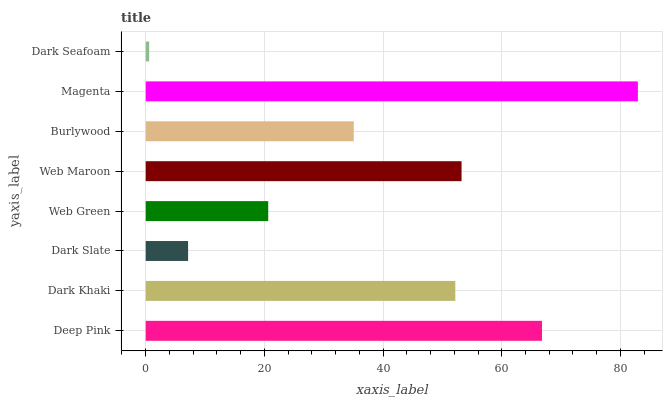Is Dark Seafoam the minimum?
Answer yes or no. Yes. Is Magenta the maximum?
Answer yes or no. Yes. Is Dark Khaki the minimum?
Answer yes or no. No. Is Dark Khaki the maximum?
Answer yes or no. No. Is Deep Pink greater than Dark Khaki?
Answer yes or no. Yes. Is Dark Khaki less than Deep Pink?
Answer yes or no. Yes. Is Dark Khaki greater than Deep Pink?
Answer yes or no. No. Is Deep Pink less than Dark Khaki?
Answer yes or no. No. Is Dark Khaki the high median?
Answer yes or no. Yes. Is Burlywood the low median?
Answer yes or no. Yes. Is Web Maroon the high median?
Answer yes or no. No. Is Web Green the low median?
Answer yes or no. No. 